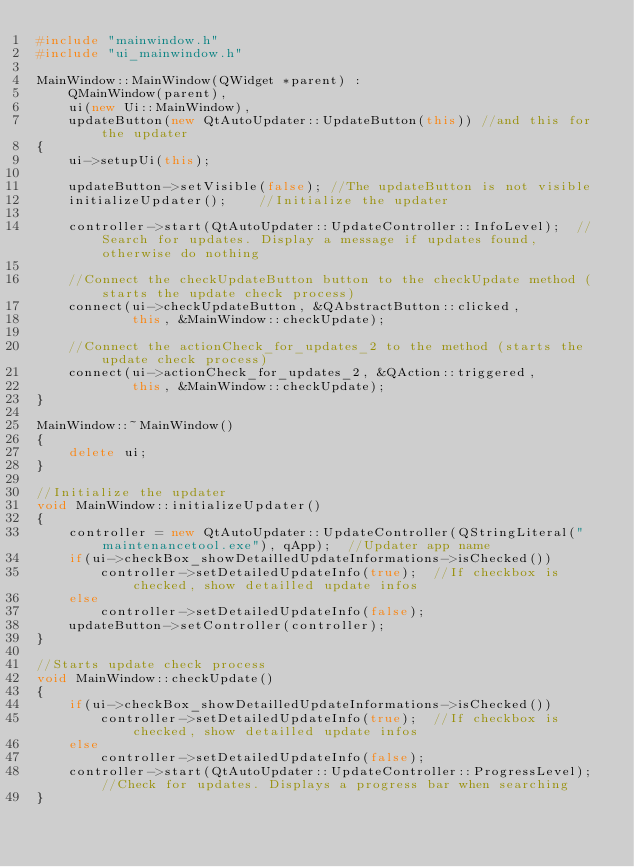<code> <loc_0><loc_0><loc_500><loc_500><_C++_>#include "mainwindow.h"
#include "ui_mainwindow.h"

MainWindow::MainWindow(QWidget *parent) :
	QMainWindow(parent),
	ui(new Ui::MainWindow),
	updateButton(new QtAutoUpdater::UpdateButton(this)) //and this for the updater
{
	ui->setupUi(this);

	updateButton->setVisible(false); //The updateButton is not visible
	initializeUpdater();	//Initialize the updater

	controller->start(QtAutoUpdater::UpdateController::InfoLevel);	//Search for updates. Display a message if updates found, otherwise do nothing

	//Connect the checkUpdateButton button to the checkUpdate method (starts the update check process)
	connect(ui->checkUpdateButton, &QAbstractButton::clicked,
			this, &MainWindow::checkUpdate);

	//Connect the actionCheck_for_updates_2 to the method (starts the update check process)
	connect(ui->actionCheck_for_updates_2, &QAction::triggered,
			this, &MainWindow::checkUpdate);
}

MainWindow::~MainWindow()
{
	delete ui;
}

//Initialize the updater
void MainWindow::initializeUpdater()
{
	controller = new QtAutoUpdater::UpdateController(QStringLiteral("maintenancetool.exe"), qApp);	//Updater app name
	if(ui->checkBox_showDetailledUpdateInformations->isChecked())
		controller->setDetailedUpdateInfo(true);  //If checkbox is checked, show detailled update infos
	else
		controller->setDetailedUpdateInfo(false);
	updateButton->setController(controller);
}

//Starts update check process
void MainWindow::checkUpdate()
{
	if(ui->checkBox_showDetailledUpdateInformations->isChecked())
		controller->setDetailedUpdateInfo(true);  //If checkbox is checked, show detailled update infos
	else 
		controller->setDetailedUpdateInfo(false);
	controller->start(QtAutoUpdater::UpdateController::ProgressLevel);	//Check for updates. Displays a progress bar when searching
}
</code> 